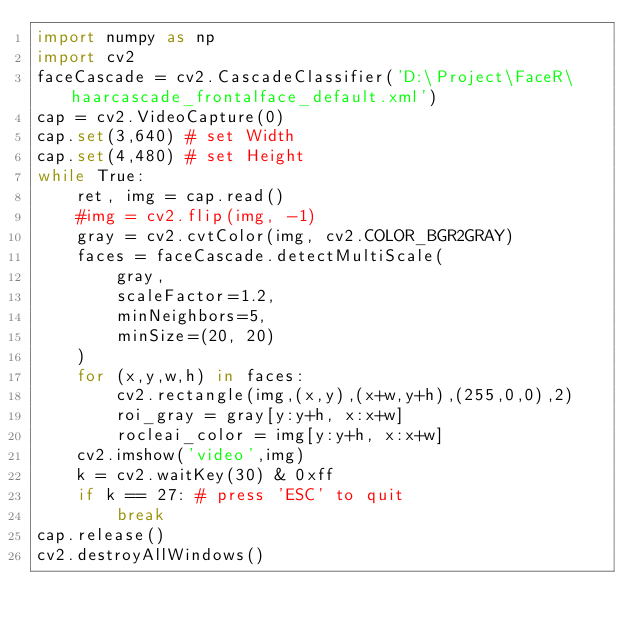<code> <loc_0><loc_0><loc_500><loc_500><_Python_>import numpy as np
import cv2
faceCascade = cv2.CascadeClassifier('D:\Project\FaceR\haarcascade_frontalface_default.xml')
cap = cv2.VideoCapture(0)
cap.set(3,640) # set Width
cap.set(4,480) # set Height
while True:
    ret, img = cap.read()
    #img = cv2.flip(img, -1)
    gray = cv2.cvtColor(img, cv2.COLOR_BGR2GRAY)
    faces = faceCascade.detectMultiScale(
        gray,     
        scaleFactor=1.2,
        minNeighbors=5,     
        minSize=(20, 20)
    )
    for (x,y,w,h) in faces:
        cv2.rectangle(img,(x,y),(x+w,y+h),(255,0,0),2)
        roi_gray = gray[y:y+h, x:x+w]
        rocleai_color = img[y:y+h, x:x+w]  
    cv2.imshow('video',img)
    k = cv2.waitKey(30) & 0xff
    if k == 27: # press 'ESC' to quit
        break
cap.release()
cv2.destroyAllWindows()</code> 